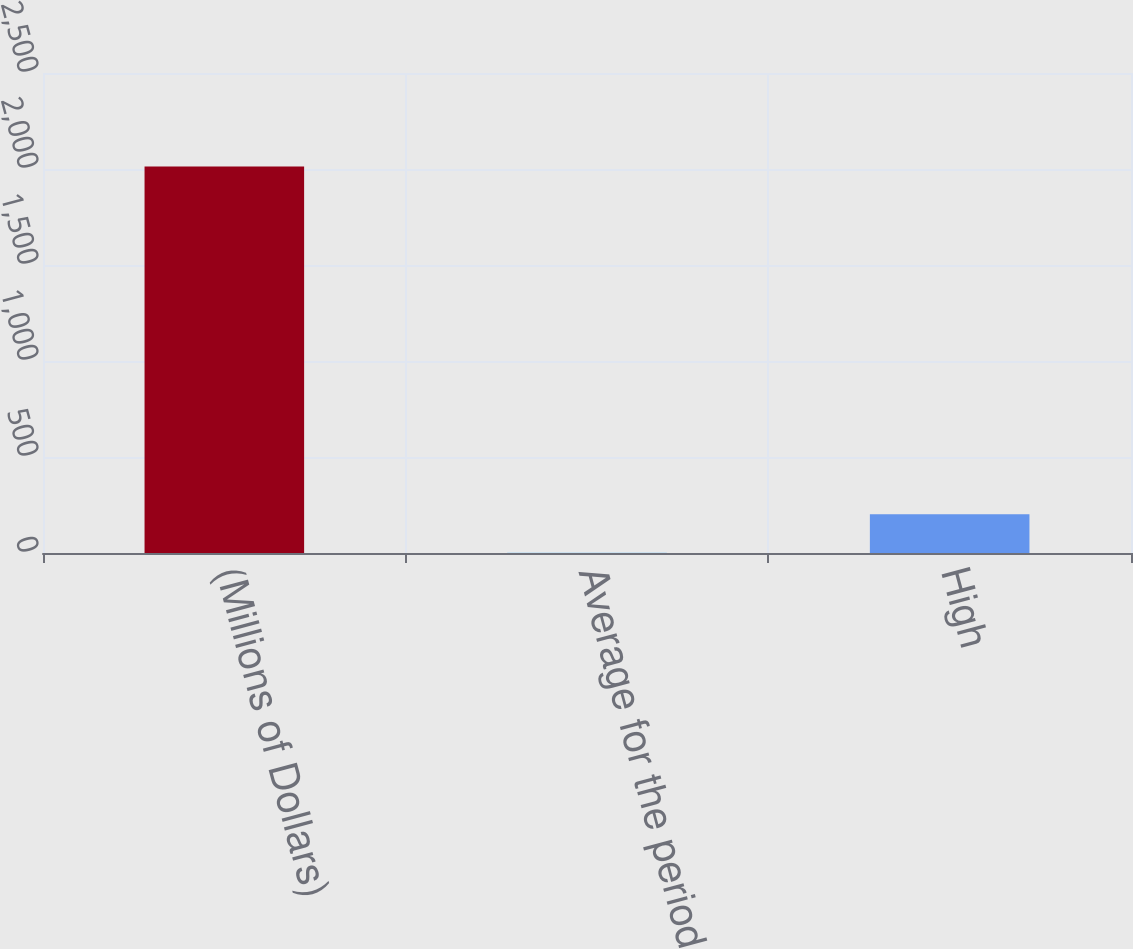<chart> <loc_0><loc_0><loc_500><loc_500><bar_chart><fcel>(Millions of Dollars)<fcel>Average for the period<fcel>High<nl><fcel>2013<fcel>1<fcel>202.2<nl></chart> 